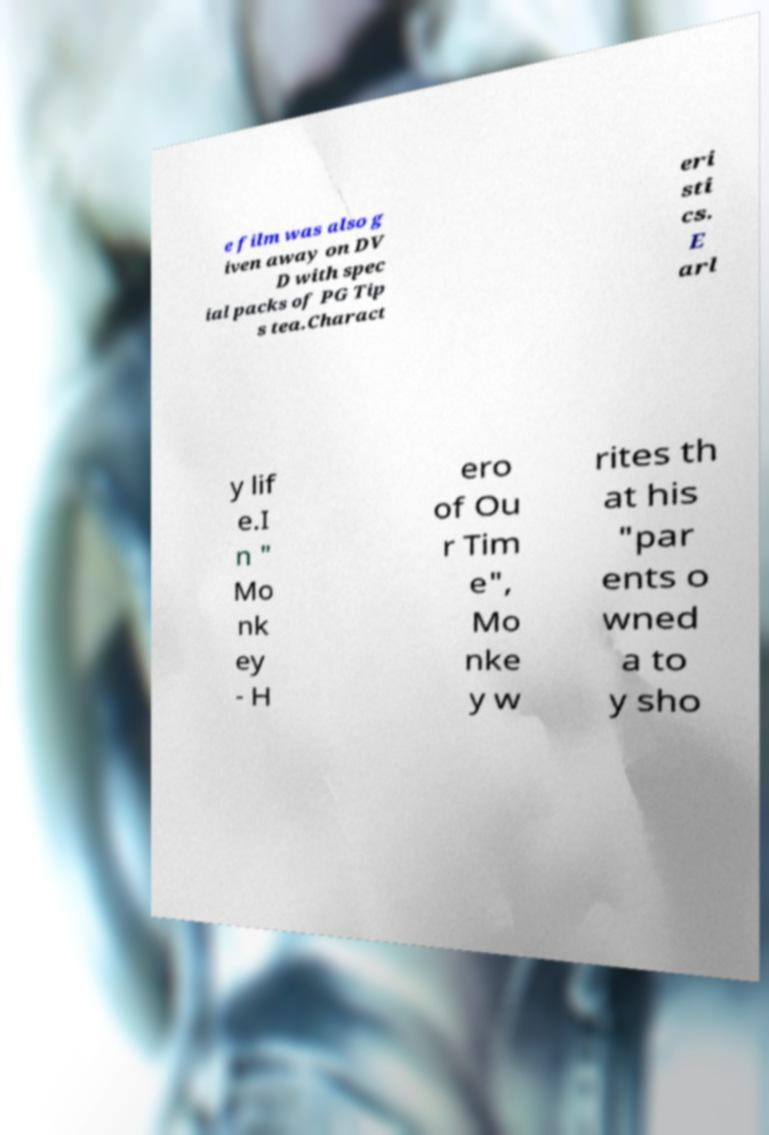I need the written content from this picture converted into text. Can you do that? e film was also g iven away on DV D with spec ial packs of PG Tip s tea.Charact eri sti cs. E arl y lif e.I n " Mo nk ey - H ero of Ou r Tim e", Mo nke y w rites th at his "par ents o wned a to y sho 